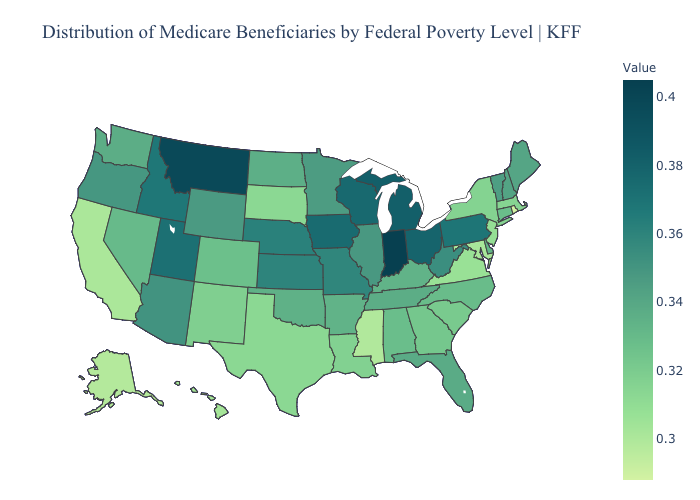Among the states that border Illinois , does Kentucky have the highest value?
Concise answer only. No. Does Virginia have the highest value in the USA?
Write a very short answer. No. Does Maine have a higher value than Missouri?
Concise answer only. No. Among the states that border South Carolina , which have the highest value?
Be succinct. North Carolina. Does Pennsylvania have the highest value in the Northeast?
Keep it brief. Yes. Does Kentucky have a lower value than South Carolina?
Keep it brief. No. Does Ohio have the highest value in the MidWest?
Be succinct. No. Does Indiana have the highest value in the USA?
Quick response, please. Yes. 